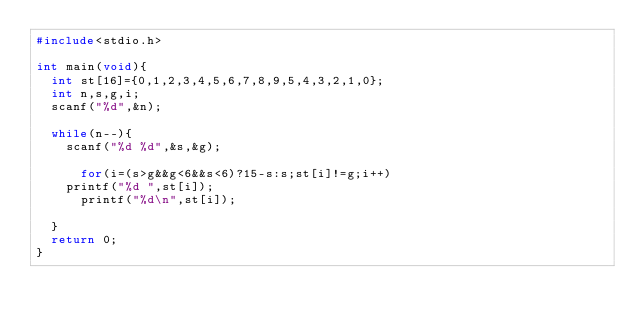<code> <loc_0><loc_0><loc_500><loc_500><_C_>#include<stdio.h>

int main(void){
  int st[16]={0,1,2,3,4,5,6,7,8,9,5,4,3,2,1,0};
  int n,s,g,i;
  scanf("%d",&n);
  
  while(n--){
    scanf("%d %d",&s,&g);

      for(i=(s>g&&g<6&&s<6)?15-s:s;st[i]!=g;i++)
	printf("%d ",st[i]);
      printf("%d\n",st[i]);

  }
  return 0;
}</code> 